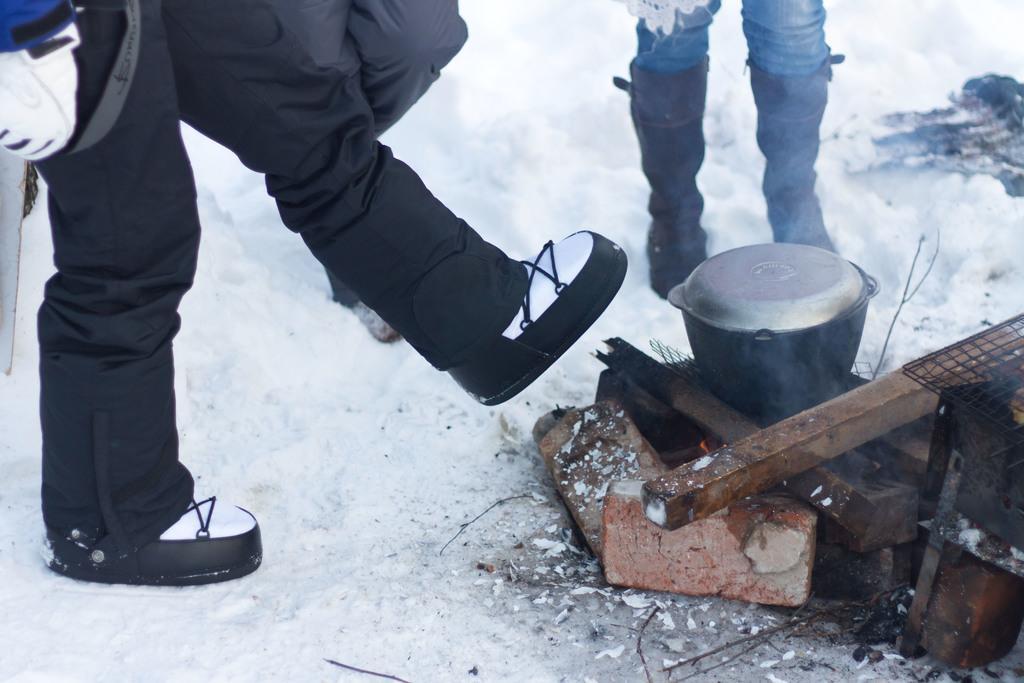In one or two sentences, can you explain what this image depicts? In this picture we can see there are two persons legs and the persons are standing on the snow. On the right side of the image, there are bricks, grill, a bowl, lid and wooden logs. 